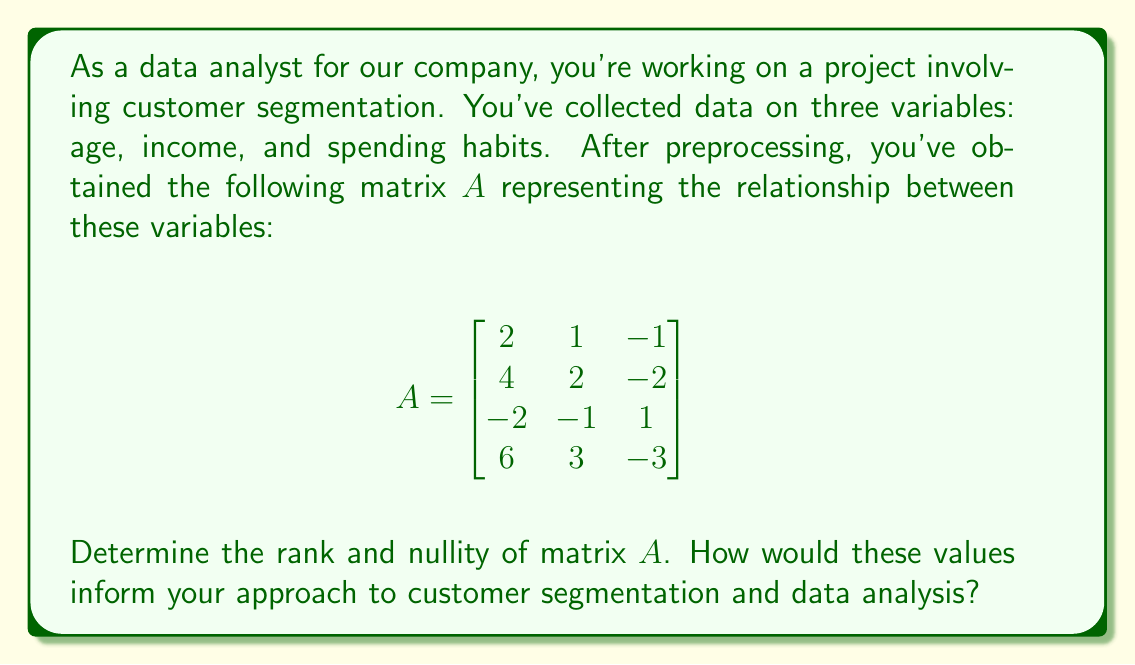Can you answer this question? To solve this problem, we'll follow these steps:

1) First, we need to find the rank of matrix $A$. The rank is the number of linearly independent rows or columns in the matrix.

2) To find the rank, we'll use Gaussian elimination to obtain the row echelon form of the matrix:

   $$\begin{bmatrix}
   2 & 1 & -1 \\
   4 & 2 & -2 \\
   -2 & -1 & 1 \\
   6 & 3 & -3
   \end{bmatrix} \sim
   \begin{bmatrix}
   2 & 1 & -1 \\
   0 & 0 & 0 \\
   0 & 0 & 0 \\
   0 & 0 & 0
   \end{bmatrix}$$

3) The rank is the number of non-zero rows in the row echelon form. Here, we see that the rank is 1.

4) The nullity of a matrix is defined as the dimension of its null space. It can be calculated using the formula:

   nullity = number of columns - rank

   In this case: nullity = 3 - 1 = 2

5) Interpretation for data analysis:
   - The rank of 1 indicates that there is only one linearly independent variable among the three we collected. This suggests that age, income, and spending habits are highly correlated in our dataset.
   - The nullity of 2 implies that there are two free variables in the system. This means that if we know one variable, we can express the other two in terms of it.

6) For customer segmentation:
   - The low rank suggests that we might be able to simplify our segmentation model by focusing on just one of these variables, as the others provide redundant information.
   - The high nullity indicates that there's a strong relationship between the variables, which could be leveraged for predictive modeling.
   - However, it also suggests that our current data might not be sufficient for complex segmentation, and we may need to collect additional, independent variables to create more nuanced customer segments.
Answer: Rank of matrix $A$ = 1
Nullity of matrix $A$ = 2

These values suggest high correlation between variables, potential for dimensionality reduction, and a need for additional independent variables for more sophisticated customer segmentation. 